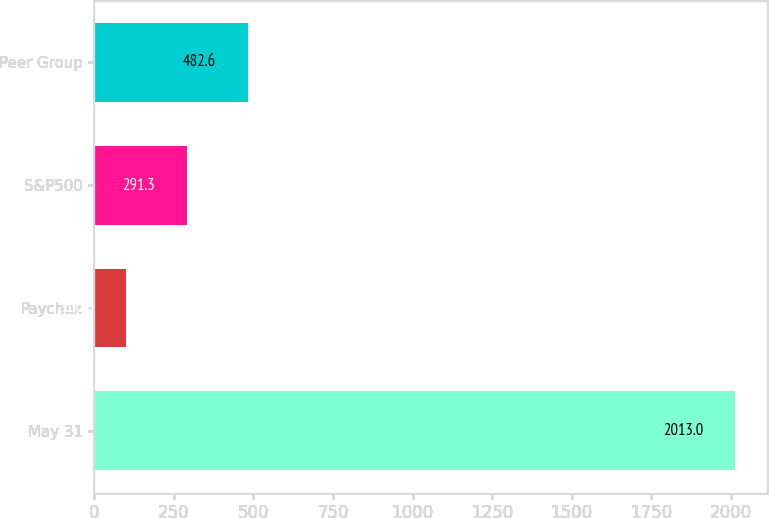Convert chart to OTSL. <chart><loc_0><loc_0><loc_500><loc_500><bar_chart><fcel>May 31<fcel>Paychex<fcel>S&P500<fcel>Peer Group<nl><fcel>2013<fcel>100<fcel>291.3<fcel>482.6<nl></chart> 